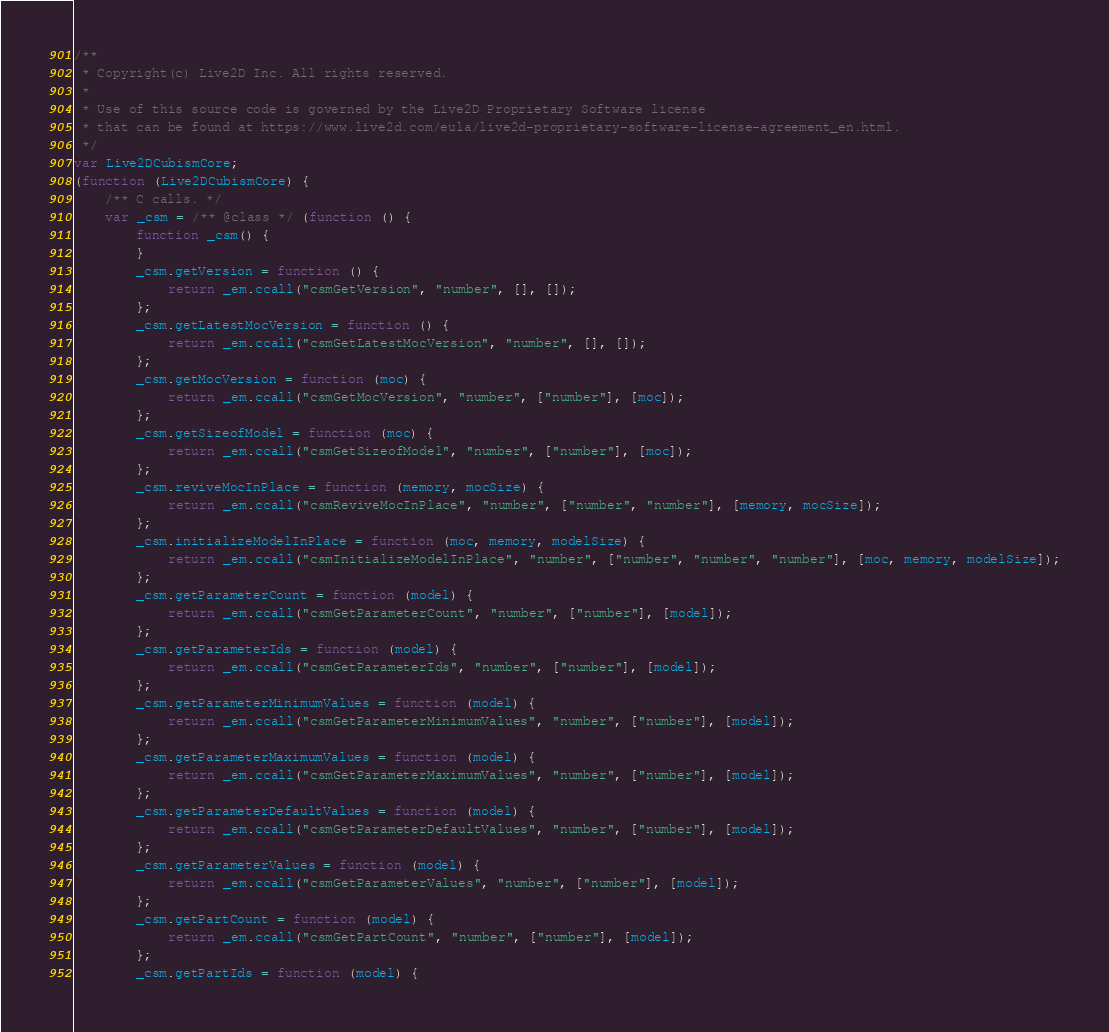Convert code to text. <code><loc_0><loc_0><loc_500><loc_500><_JavaScript_>/**
 * Copyright(c) Live2D Inc. All rights reserved.
 *
 * Use of this source code is governed by the Live2D Proprietary Software license
 * that can be found at https://www.live2d.com/eula/live2d-proprietary-software-license-agreement_en.html.
 */
var Live2DCubismCore;
(function (Live2DCubismCore) {
    /** C calls. */
    var _csm = /** @class */ (function () {
        function _csm() {
        }
        _csm.getVersion = function () {
            return _em.ccall("csmGetVersion", "number", [], []);
        };
        _csm.getLatestMocVersion = function () {
            return _em.ccall("csmGetLatestMocVersion", "number", [], []);
        };
        _csm.getMocVersion = function (moc) {
            return _em.ccall("csmGetMocVersion", "number", ["number"], [moc]);
        };
        _csm.getSizeofModel = function (moc) {
            return _em.ccall("csmGetSizeofModel", "number", ["number"], [moc]);
        };
        _csm.reviveMocInPlace = function (memory, mocSize) {
            return _em.ccall("csmReviveMocInPlace", "number", ["number", "number"], [memory, mocSize]);
        };
        _csm.initializeModelInPlace = function (moc, memory, modelSize) {
            return _em.ccall("csmInitializeModelInPlace", "number", ["number", "number", "number"], [moc, memory, modelSize]);
        };
        _csm.getParameterCount = function (model) {
            return _em.ccall("csmGetParameterCount", "number", ["number"], [model]);
        };
        _csm.getParameterIds = function (model) {
            return _em.ccall("csmGetParameterIds", "number", ["number"], [model]);
        };
        _csm.getParameterMinimumValues = function (model) {
            return _em.ccall("csmGetParameterMinimumValues", "number", ["number"], [model]);
        };
        _csm.getParameterMaximumValues = function (model) {
            return _em.ccall("csmGetParameterMaximumValues", "number", ["number"], [model]);
        };
        _csm.getParameterDefaultValues = function (model) {
            return _em.ccall("csmGetParameterDefaultValues", "number", ["number"], [model]);
        };
        _csm.getParameterValues = function (model) {
            return _em.ccall("csmGetParameterValues", "number", ["number"], [model]);
        };
        _csm.getPartCount = function (model) {
            return _em.ccall("csmGetPartCount", "number", ["number"], [model]);
        };
        _csm.getPartIds = function (model) {</code> 